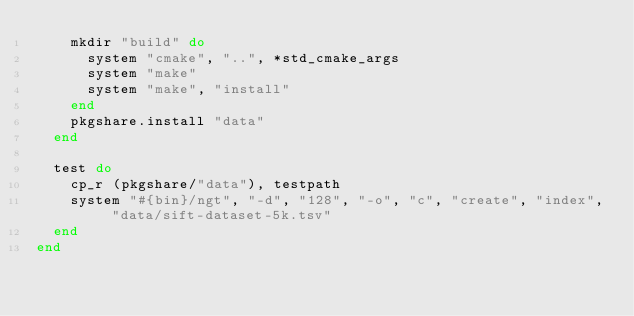<code> <loc_0><loc_0><loc_500><loc_500><_Ruby_>    mkdir "build" do
      system "cmake", "..", *std_cmake_args
      system "make"
      system "make", "install"
    end
    pkgshare.install "data"
  end

  test do
    cp_r (pkgshare/"data"), testpath
    system "#{bin}/ngt", "-d", "128", "-o", "c", "create", "index", "data/sift-dataset-5k.tsv"
  end
end
</code> 